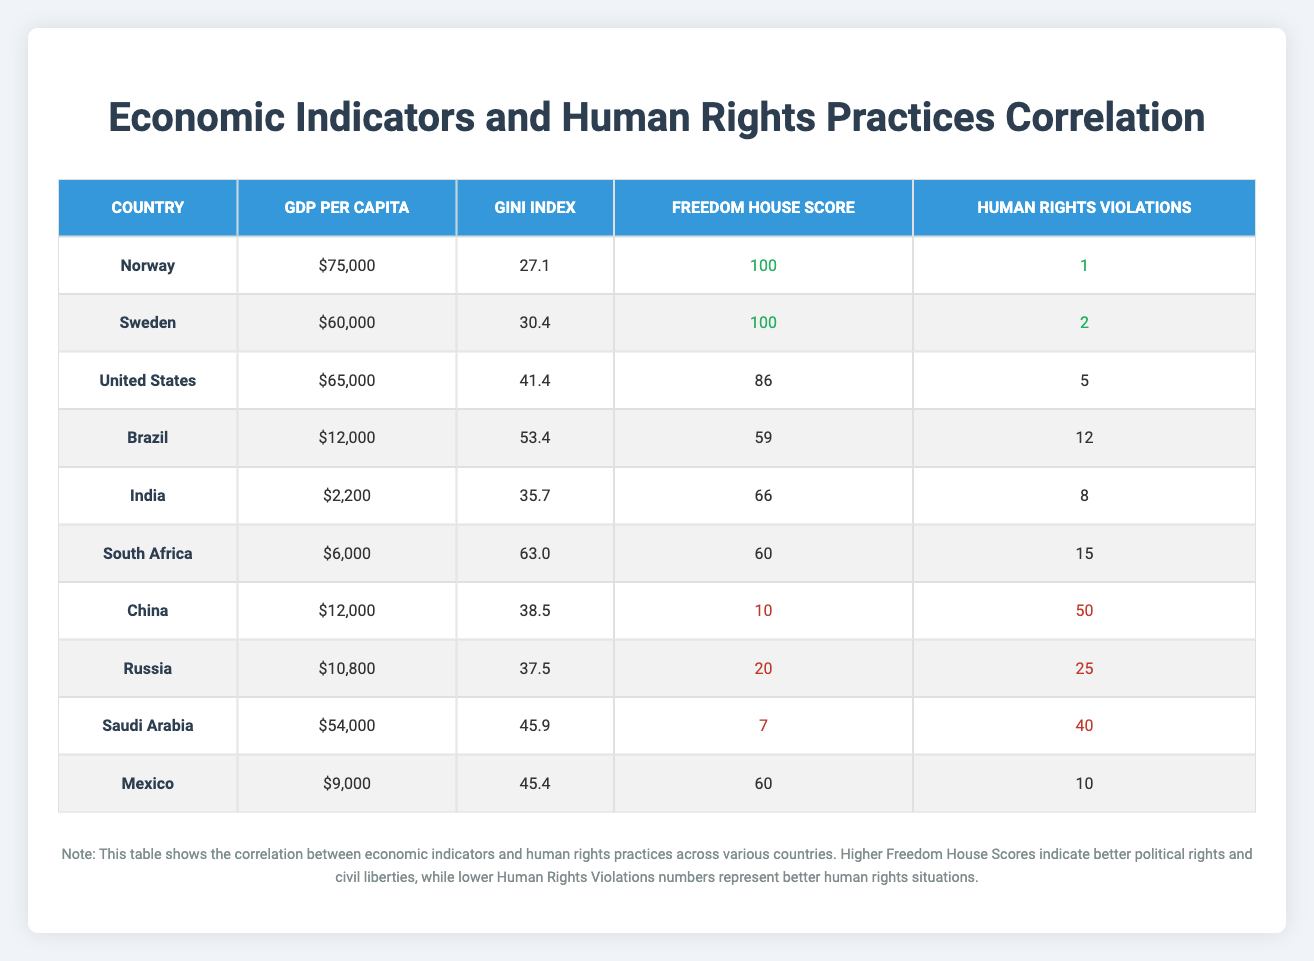What is the GDP per capita of Saudi Arabia? From the table, the row for Saudi Arabia shows that its GDP per capita is $54,000.
Answer: $54,000 Which country has the highest Freedom House Score? Looking at the Freedom House Score column, both Norway and Sweden have the highest score of 100.
Answer: Norway and Sweden What is the average Gini Index of the countries listed? The Gini Index values are 27.1, 30.4, 41.4, 53.4, 35.7, 63.0, 38.5, 37.5, 45.9, and 45.4. Summing these values gives a total of 413.9. There are 10 countries, so the average is 413.9 / 10 = 41.39.
Answer: 41.39 Is it true that China has a lower Freedom House Score than Saudi Arabia? The Freedom House score for China is 10, while for Saudi Arabia it is 7. Since 10 is greater than 7, the statement is false.
Answer: No If we consider human rights violations, which country experiences the most violations in the table? From the Human Rights Violations column, the maximum value is 50 for China. Hence, China experiences the most human rights violations according to the table.
Answer: China What is the difference in GDP per capita between Norway and Brazil? Norway's GDP per capita is $75,000 and Brazil's is $12,000. The difference is $75,000 - $12,000 = $63,000.
Answer: $63,000 Which country has a higher GDP per capita: the United States or Mexico? The GDP per capita for the United States is $65,000, while for Mexico it is $9,000. Since $65,000 is greater than $9,000, the United States has a higher GDP per capita.
Answer: United States What percentage of human rights violations does Norway represent relative to the country with the highest violations? Norway has 1 human rights violation while China has 50. The percentage is (1 / 50) * 100 = 2%.
Answer: 2% How many countries have a Freedom House Score below 60? Reviewing the Freedom House Score column, China (10), Saudi Arabia (7), and Russia (20) all fall below 60. That's a total of 3 countries.
Answer: 3 